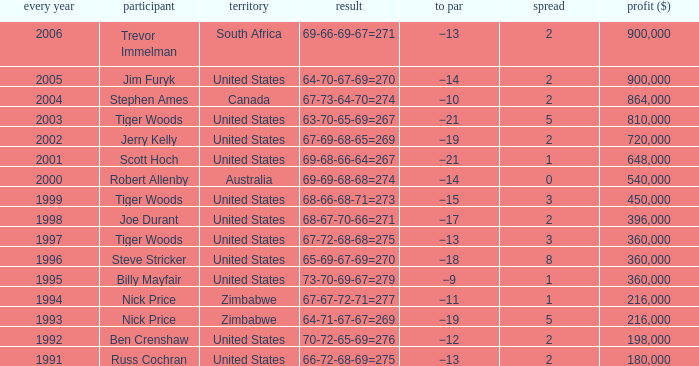What is russ cochran's average margin? 2.0. Parse the full table. {'header': ['every year', 'participant', 'territory', 'result', 'to par', 'spread', 'profit ($)'], 'rows': [['2006', 'Trevor Immelman', 'South Africa', '69-66-69-67=271', '−13', '2', '900,000'], ['2005', 'Jim Furyk', 'United States', '64-70-67-69=270', '−14', '2', '900,000'], ['2004', 'Stephen Ames', 'Canada', '67-73-64-70=274', '−10', '2', '864,000'], ['2003', 'Tiger Woods', 'United States', '63-70-65-69=267', '−21', '5', '810,000'], ['2002', 'Jerry Kelly', 'United States', '67-69-68-65=269', '−19', '2', '720,000'], ['2001', 'Scott Hoch', 'United States', '69-68-66-64=267', '−21', '1', '648,000'], ['2000', 'Robert Allenby', 'Australia', '69-69-68-68=274', '−14', '0', '540,000'], ['1999', 'Tiger Woods', 'United States', '68-66-68-71=273', '−15', '3', '450,000'], ['1998', 'Joe Durant', 'United States', '68-67-70-66=271', '−17', '2', '396,000'], ['1997', 'Tiger Woods', 'United States', '67-72-68-68=275', '−13', '3', '360,000'], ['1996', 'Steve Stricker', 'United States', '65-69-67-69=270', '−18', '8', '360,000'], ['1995', 'Billy Mayfair', 'United States', '73-70-69-67=279', '−9', '1', '360,000'], ['1994', 'Nick Price', 'Zimbabwe', '67-67-72-71=277', '−11', '1', '216,000'], ['1993', 'Nick Price', 'Zimbabwe', '64-71-67-67=269', '−19', '5', '216,000'], ['1992', 'Ben Crenshaw', 'United States', '70-72-65-69=276', '−12', '2', '198,000'], ['1991', 'Russ Cochran', 'United States', '66-72-68-69=275', '−13', '2', '180,000']]} 